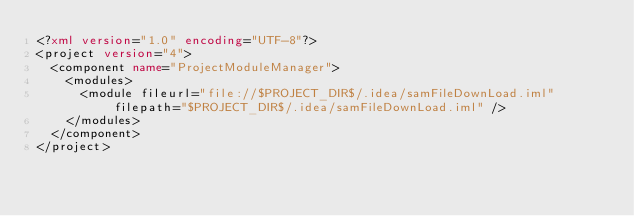<code> <loc_0><loc_0><loc_500><loc_500><_XML_><?xml version="1.0" encoding="UTF-8"?>
<project version="4">
  <component name="ProjectModuleManager">
    <modules>
      <module fileurl="file://$PROJECT_DIR$/.idea/samFileDownLoad.iml" filepath="$PROJECT_DIR$/.idea/samFileDownLoad.iml" />
    </modules>
  </component>
</project></code> 